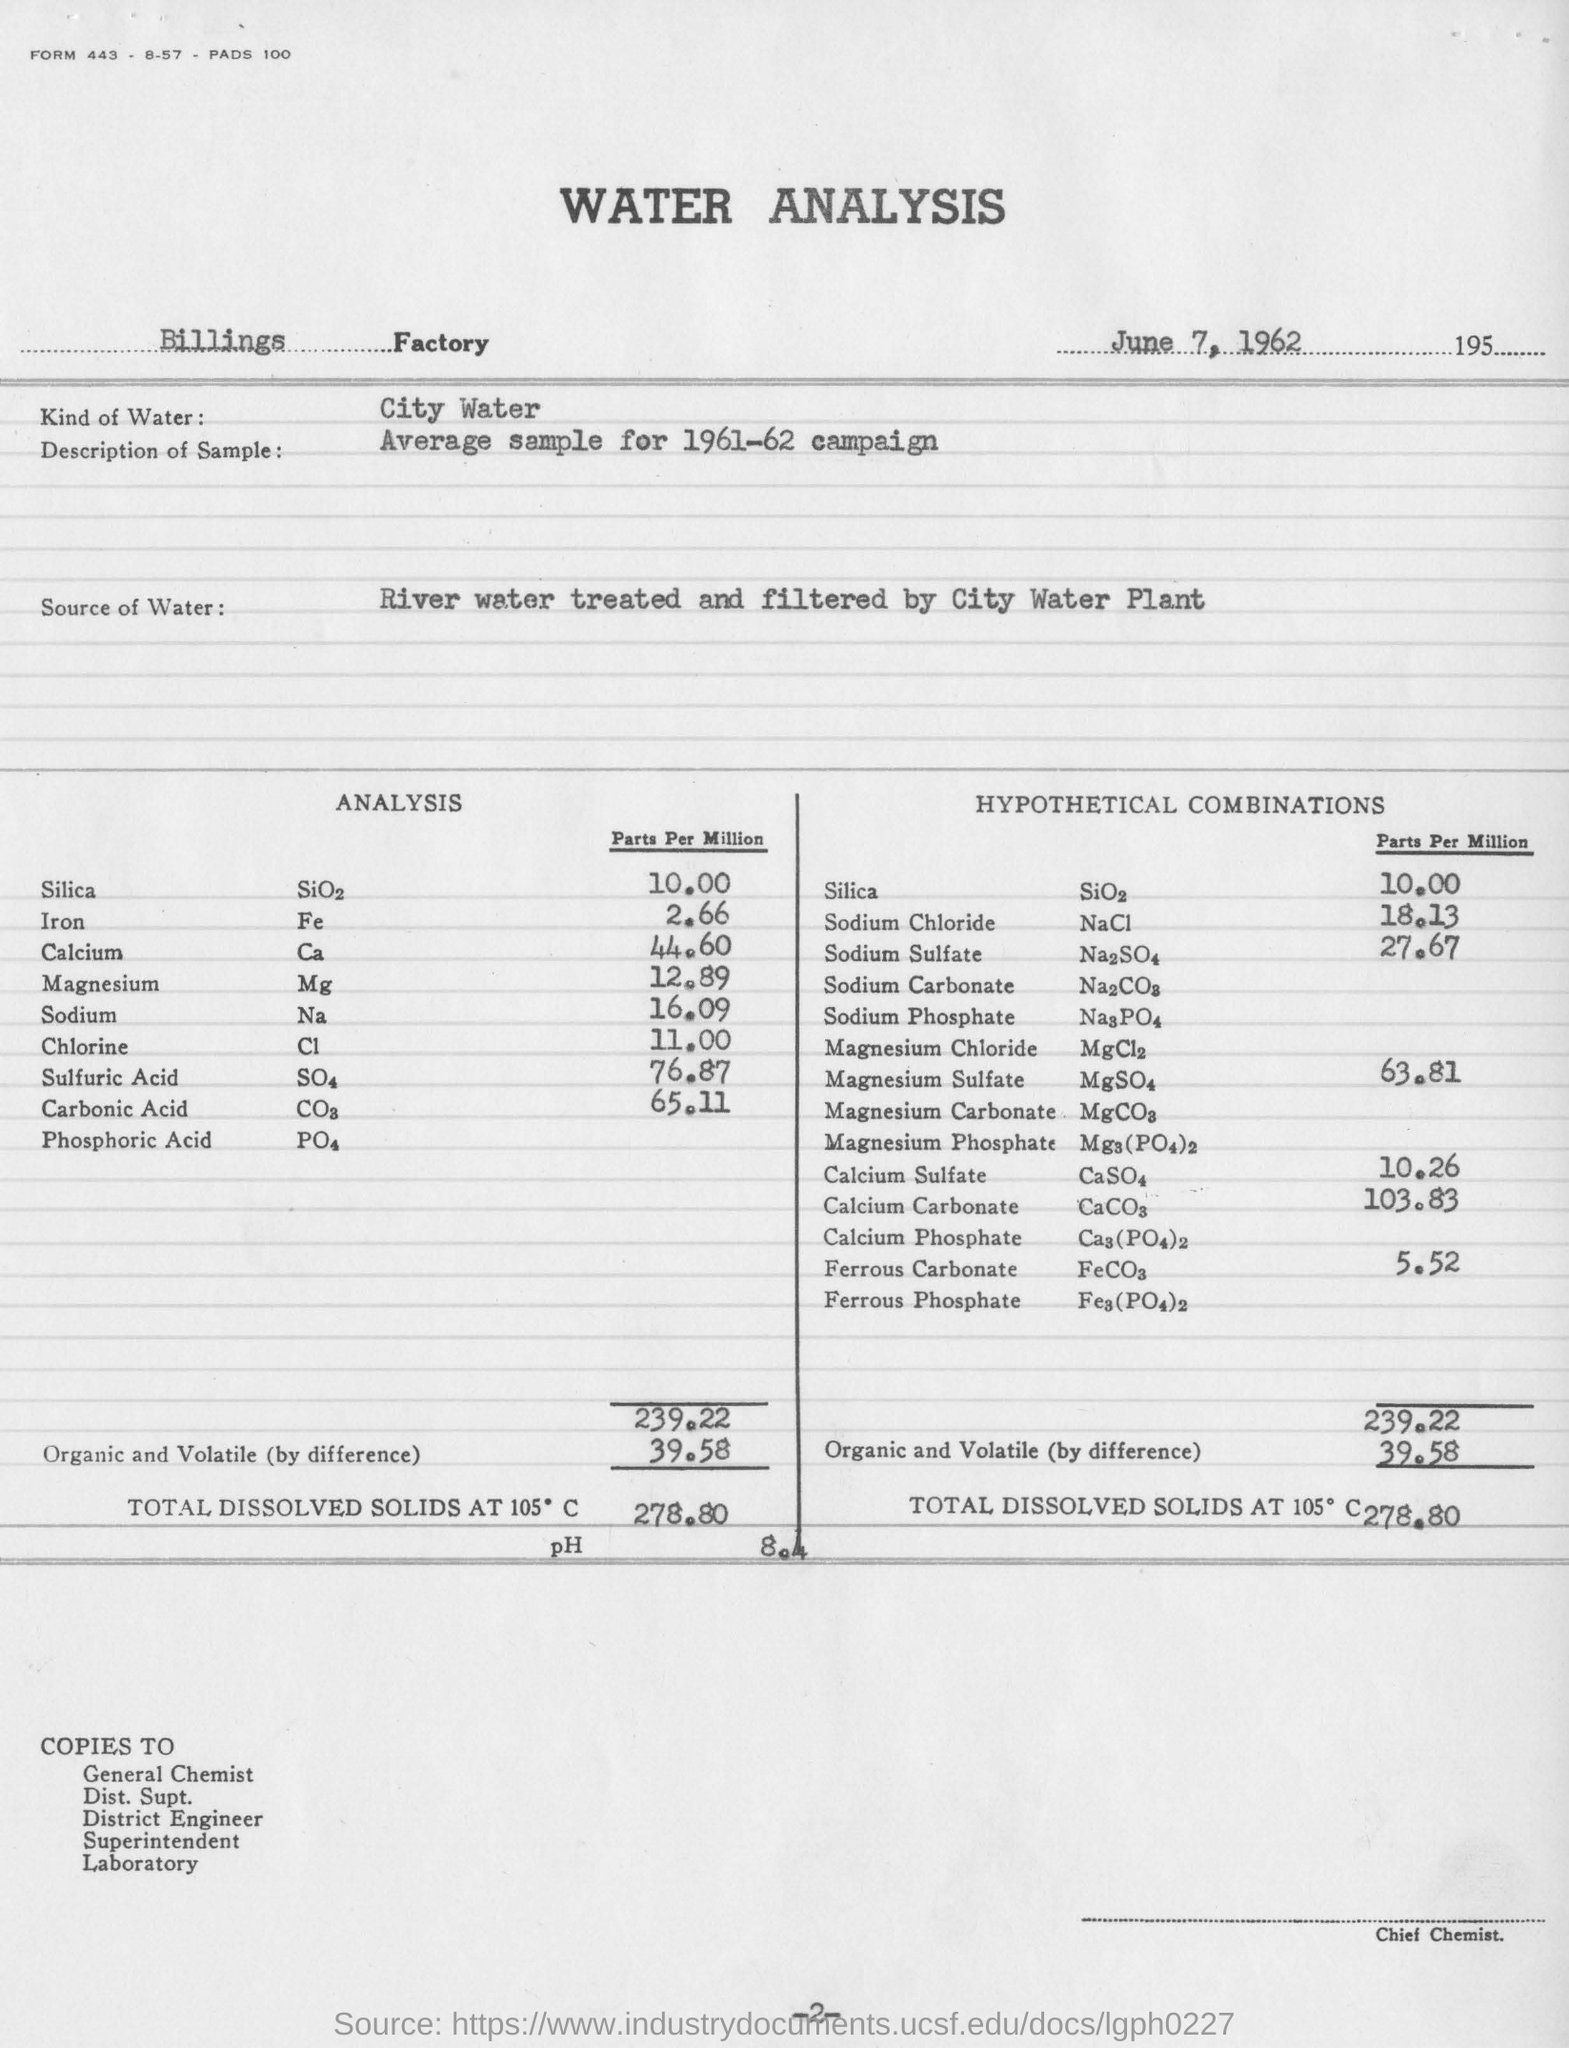Which factory is mentioned?
Your answer should be compact. Billings Factory. What  kind of water was used in the analysis?
Give a very brief answer. City water. What is the date of analysis?
Your answer should be very brief. June 7, 1962. 